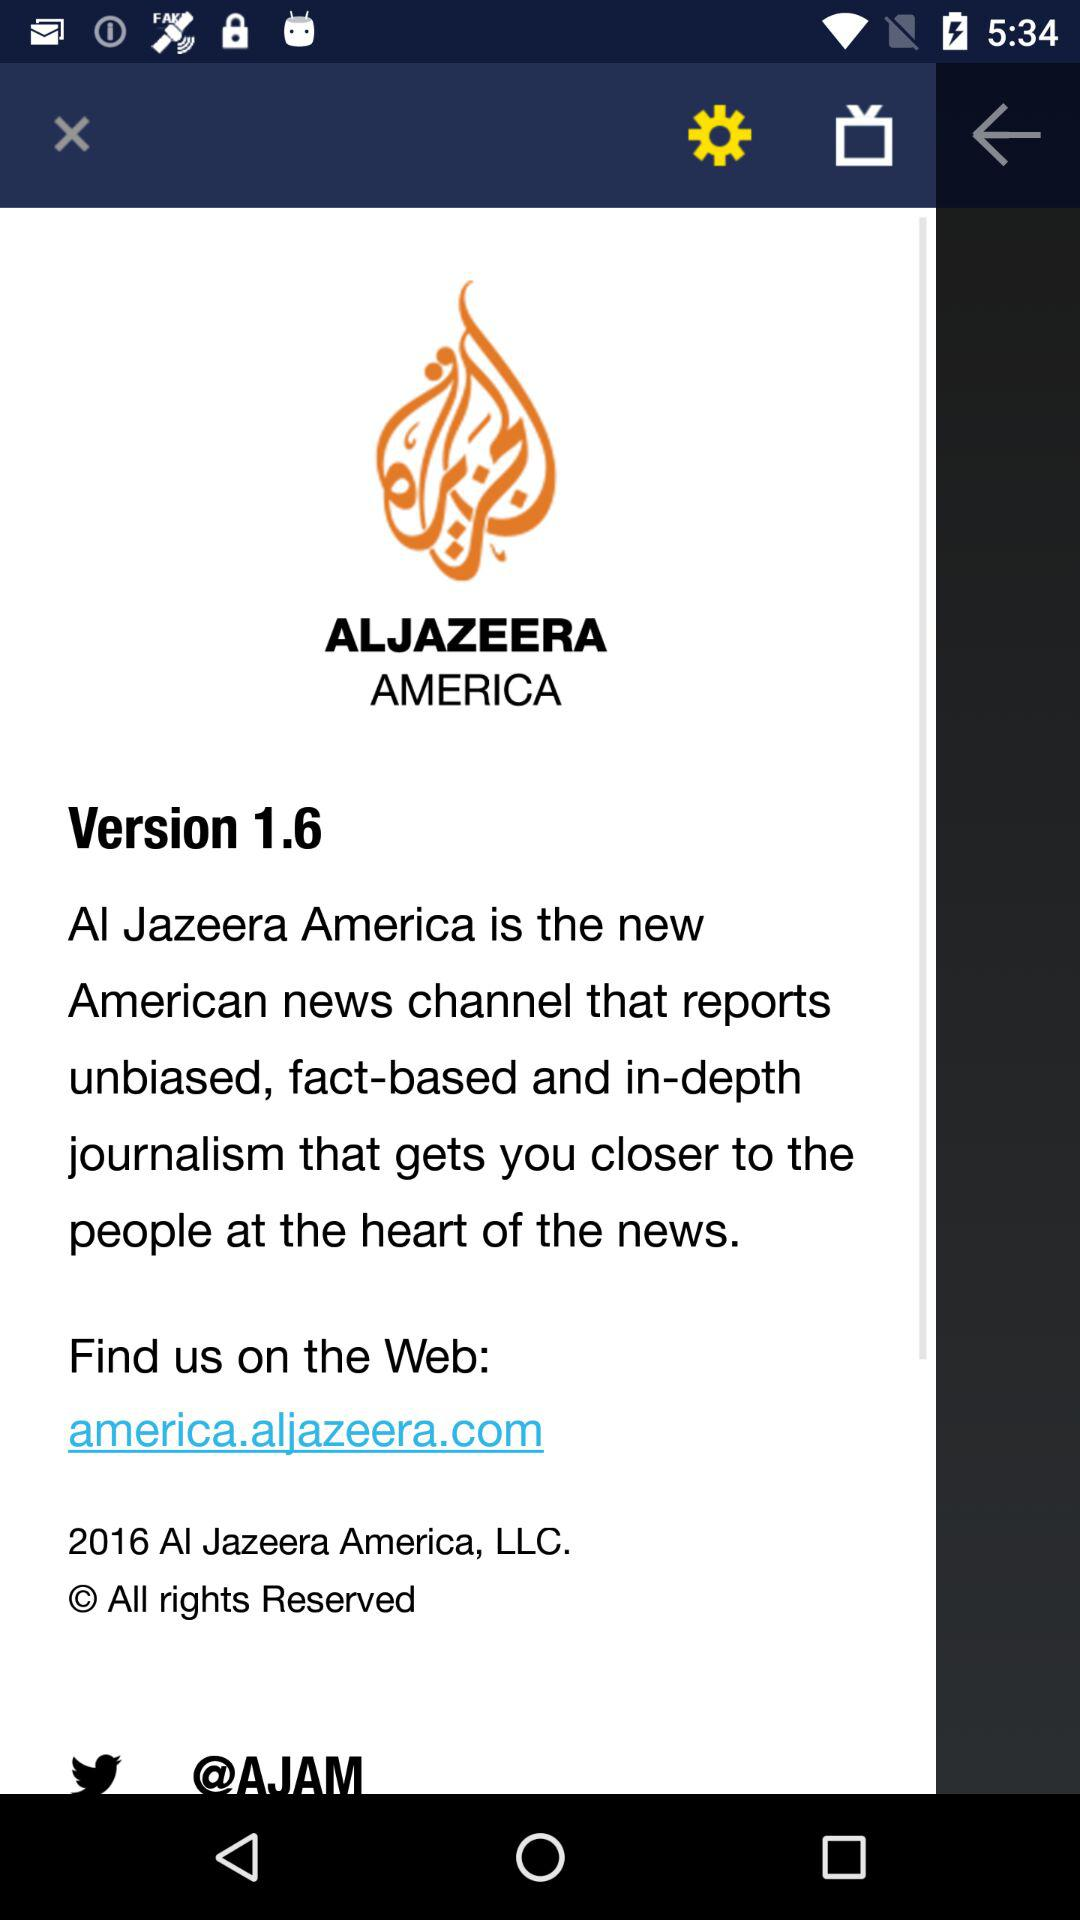What is the year of copyright for the application? The year of copyright for the application is 2016. 